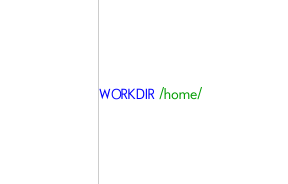<code> <loc_0><loc_0><loc_500><loc_500><_Dockerfile_>WORKDIR /home/
</code> 